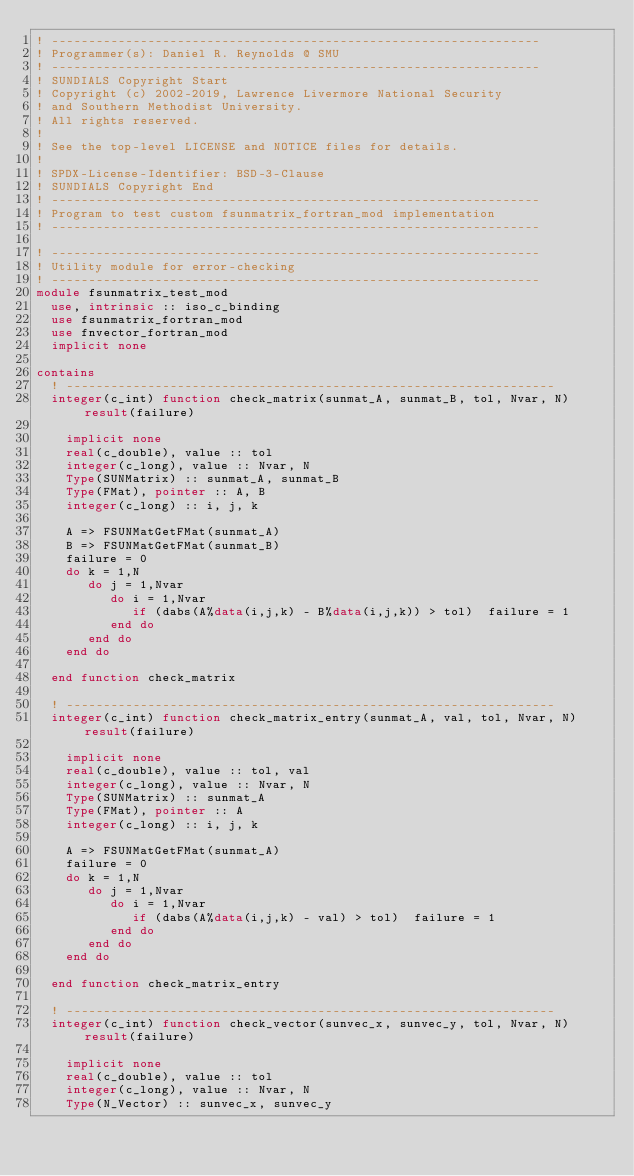Convert code to text. <code><loc_0><loc_0><loc_500><loc_500><_FORTRAN_>! ------------------------------------------------------------------
! Programmer(s): Daniel R. Reynolds @ SMU
! ------------------------------------------------------------------
! SUNDIALS Copyright Start
! Copyright (c) 2002-2019, Lawrence Livermore National Security
! and Southern Methodist University.
! All rights reserved.
!
! See the top-level LICENSE and NOTICE files for details.
!
! SPDX-License-Identifier: BSD-3-Clause
! SUNDIALS Copyright End
! ------------------------------------------------------------------
! Program to test custom fsunmatrix_fortran_mod implementation
! ------------------------------------------------------------------

! ------------------------------------------------------------------
! Utility module for error-checking
! ------------------------------------------------------------------
module fsunmatrix_test_mod
  use, intrinsic :: iso_c_binding
  use fsunmatrix_fortran_mod
  use fnvector_fortran_mod
  implicit none

contains
  ! ------------------------------------------------------------------
  integer(c_int) function check_matrix(sunmat_A, sunmat_B, tol, Nvar, N) result(failure)

    implicit none
    real(c_double), value :: tol
    integer(c_long), value :: Nvar, N
    Type(SUNMatrix) :: sunmat_A, sunmat_B
    Type(FMat), pointer :: A, B
    integer(c_long) :: i, j, k

    A => FSUNMatGetFMat(sunmat_A)
    B => FSUNMatGetFMat(sunmat_B)
    failure = 0
    do k = 1,N
       do j = 1,Nvar
          do i = 1,Nvar
             if (dabs(A%data(i,j,k) - B%data(i,j,k)) > tol)  failure = 1
          end do
       end do
    end do

  end function check_matrix

  ! ------------------------------------------------------------------
  integer(c_int) function check_matrix_entry(sunmat_A, val, tol, Nvar, N) result(failure)

    implicit none
    real(c_double), value :: tol, val
    integer(c_long), value :: Nvar, N
    Type(SUNMatrix) :: sunmat_A
    Type(FMat), pointer :: A
    integer(c_long) :: i, j, k

    A => FSUNMatGetFMat(sunmat_A)
    failure = 0
    do k = 1,N
       do j = 1,Nvar
          do i = 1,Nvar
             if (dabs(A%data(i,j,k) - val) > tol)  failure = 1
          end do
       end do
    end do

  end function check_matrix_entry

  ! ------------------------------------------------------------------
  integer(c_int) function check_vector(sunvec_x, sunvec_y, tol, Nvar, N) result(failure)

    implicit none
    real(c_double), value :: tol
    integer(c_long), value :: Nvar, N
    Type(N_Vector) :: sunvec_x, sunvec_y</code> 